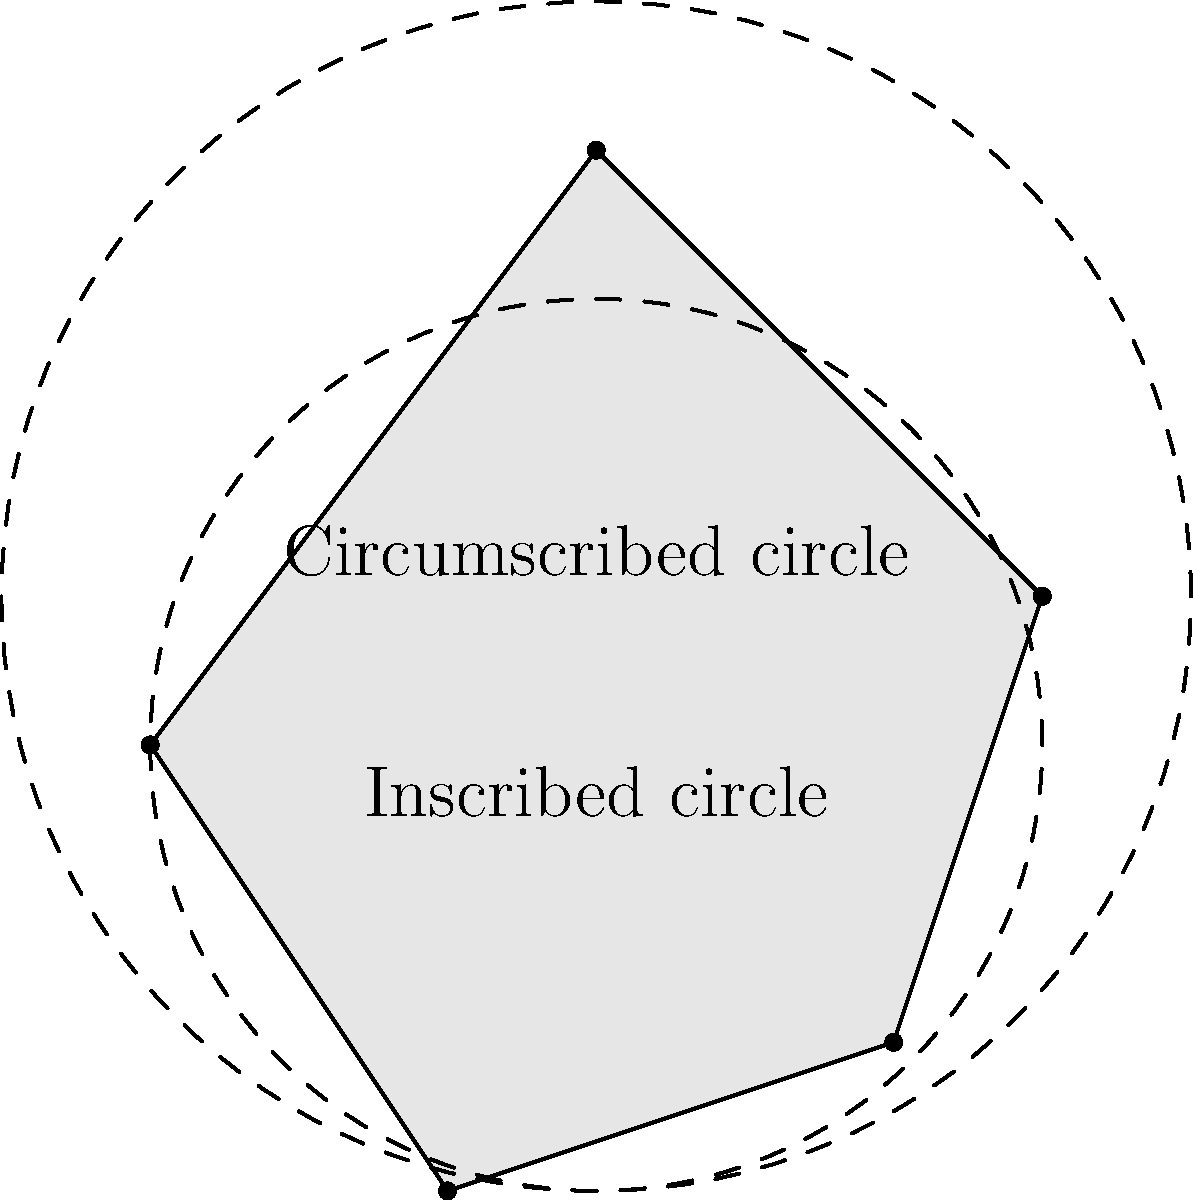A sediment deposit has an irregular shape as shown in the figure. To estimate its area, you inscribe a circle with radius 3 units and circumscribe another circle with radius 4 units. What is the best estimate for the area of the sediment deposit in square units? To estimate the area of the irregular sediment deposit, we can use the areas of the inscribed and circumscribed circles as lower and upper bounds, respectively. Then, we can take their average as a reasonable estimate.

Step 1: Calculate the area of the inscribed circle (lower bound)
$A_1 = \pi r_1^2 = \pi (3)^2 = 9\pi$ square units

Step 2: Calculate the area of the circumscribed circle (upper bound)
$A_2 = \pi r_2^2 = \pi (4)^2 = 16\pi$ square units

Step 3: Calculate the average of the two areas
$A_{estimated} = \frac{A_1 + A_2}{2} = \frac{9\pi + 16\pi}{2} = \frac{25\pi}{2} = 12.5\pi$ square units

Step 4: Round the result to a reasonable number of significant figures
$A_{estimated} \approx 39.3$ square units (rounded to three significant figures)

This method provides a reasonable estimate for the area of the irregular sediment deposit, considering that its actual shape falls between the inscribed and circumscribed circles.
Answer: 39.3 square units 